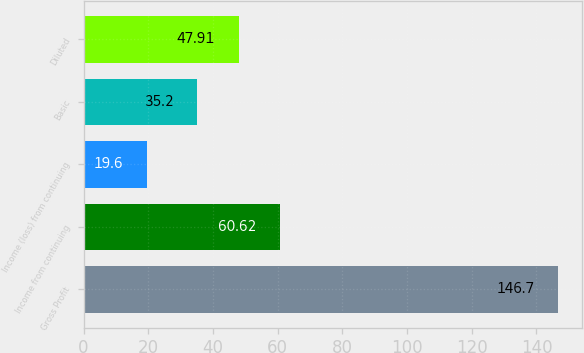Convert chart. <chart><loc_0><loc_0><loc_500><loc_500><bar_chart><fcel>Gross Profit<fcel>Income from continuing<fcel>Income (loss) from continuing<fcel>Basic<fcel>Diluted<nl><fcel>146.7<fcel>60.62<fcel>19.6<fcel>35.2<fcel>47.91<nl></chart> 